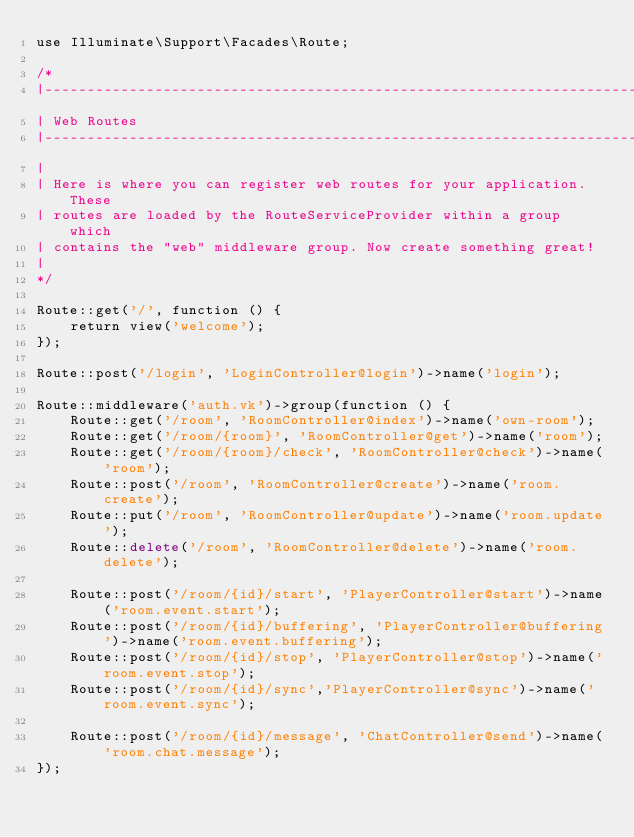Convert code to text. <code><loc_0><loc_0><loc_500><loc_500><_PHP_>use Illuminate\Support\Facades\Route;

/*
|--------------------------------------------------------------------------
| Web Routes
|--------------------------------------------------------------------------
|
| Here is where you can register web routes for your application. These
| routes are loaded by the RouteServiceProvider within a group which
| contains the "web" middleware group. Now create something great!
|
*/

Route::get('/', function () {
    return view('welcome');
});

Route::post('/login', 'LoginController@login')->name('login');

Route::middleware('auth.vk')->group(function () {
    Route::get('/room', 'RoomController@index')->name('own-room');
    Route::get('/room/{room}', 'RoomController@get')->name('room');
    Route::get('/room/{room}/check', 'RoomController@check')->name('room');
    Route::post('/room', 'RoomController@create')->name('room.create');
    Route::put('/room', 'RoomController@update')->name('room.update');
    Route::delete('/room', 'RoomController@delete')->name('room.delete');

    Route::post('/room/{id}/start', 'PlayerController@start')->name('room.event.start');
    Route::post('/room/{id}/buffering', 'PlayerController@buffering')->name('room.event.buffering');
    Route::post('/room/{id}/stop', 'PlayerController@stop')->name('room.event.stop');
    Route::post('/room/{id}/sync','PlayerController@sync')->name('room.event.sync');

    Route::post('/room/{id}/message', 'ChatController@send')->name('room.chat.message');
});
</code> 